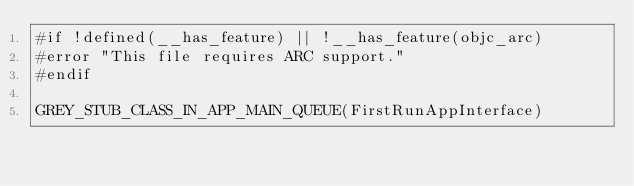Convert code to text. <code><loc_0><loc_0><loc_500><loc_500><_ObjectiveC_>#if !defined(__has_feature) || !__has_feature(objc_arc)
#error "This file requires ARC support."
#endif

GREY_STUB_CLASS_IN_APP_MAIN_QUEUE(FirstRunAppInterface)
</code> 